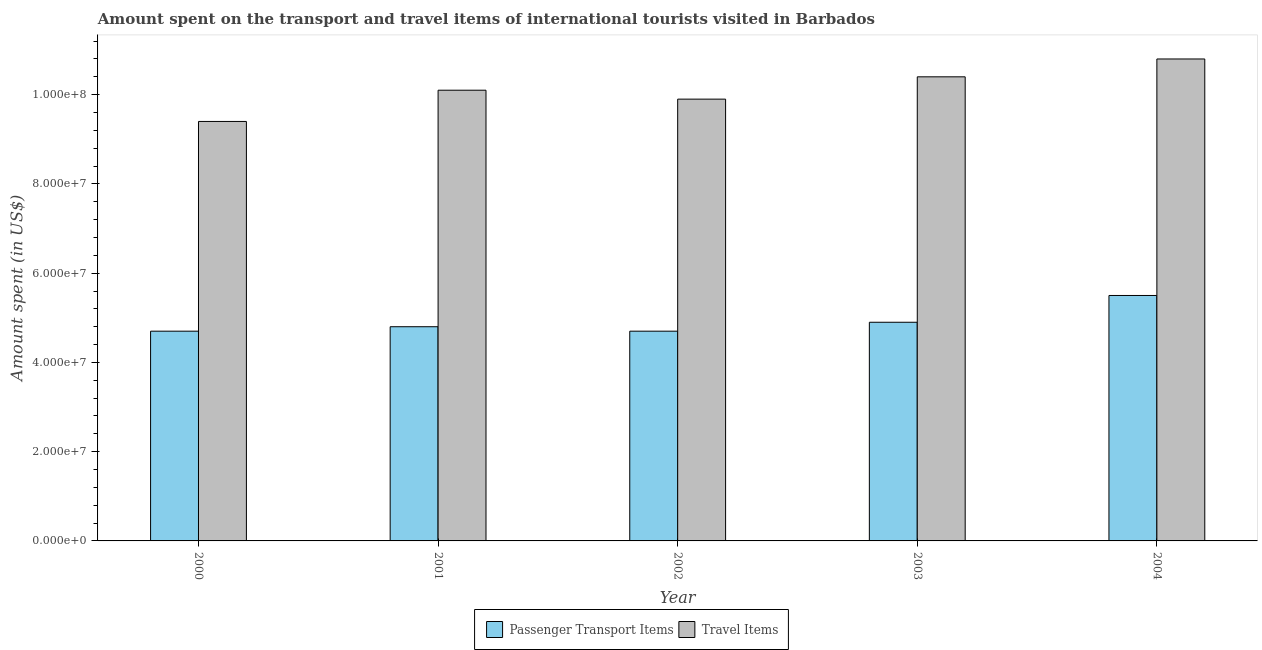How many groups of bars are there?
Offer a terse response. 5. How many bars are there on the 4th tick from the right?
Give a very brief answer. 2. What is the label of the 1st group of bars from the left?
Provide a short and direct response. 2000. What is the amount spent on passenger transport items in 2003?
Make the answer very short. 4.90e+07. Across all years, what is the maximum amount spent on passenger transport items?
Give a very brief answer. 5.50e+07. Across all years, what is the minimum amount spent on passenger transport items?
Ensure brevity in your answer.  4.70e+07. In which year was the amount spent in travel items minimum?
Provide a succinct answer. 2000. What is the total amount spent on passenger transport items in the graph?
Provide a succinct answer. 2.46e+08. What is the difference between the amount spent in travel items in 2001 and that in 2004?
Give a very brief answer. -7.00e+06. What is the difference between the amount spent in travel items in 2000 and the amount spent on passenger transport items in 2003?
Your answer should be compact. -1.00e+07. What is the average amount spent on passenger transport items per year?
Provide a short and direct response. 4.92e+07. In the year 2002, what is the difference between the amount spent in travel items and amount spent on passenger transport items?
Your answer should be very brief. 0. In how many years, is the amount spent in travel items greater than 52000000 US$?
Make the answer very short. 5. What is the ratio of the amount spent in travel items in 2001 to that in 2003?
Keep it short and to the point. 0.97. Is the amount spent on passenger transport items in 2001 less than that in 2004?
Keep it short and to the point. Yes. What is the difference between the highest and the second highest amount spent on passenger transport items?
Provide a succinct answer. 6.00e+06. What is the difference between the highest and the lowest amount spent on passenger transport items?
Your response must be concise. 8.00e+06. In how many years, is the amount spent on passenger transport items greater than the average amount spent on passenger transport items taken over all years?
Your answer should be very brief. 1. Is the sum of the amount spent in travel items in 2002 and 2003 greater than the maximum amount spent on passenger transport items across all years?
Make the answer very short. Yes. What does the 2nd bar from the left in 2002 represents?
Keep it short and to the point. Travel Items. What does the 2nd bar from the right in 2002 represents?
Your answer should be very brief. Passenger Transport Items. Are all the bars in the graph horizontal?
Your answer should be compact. No. Does the graph contain any zero values?
Your answer should be very brief. No. Does the graph contain grids?
Offer a very short reply. No. How are the legend labels stacked?
Your response must be concise. Horizontal. What is the title of the graph?
Offer a terse response. Amount spent on the transport and travel items of international tourists visited in Barbados. What is the label or title of the X-axis?
Give a very brief answer. Year. What is the label or title of the Y-axis?
Offer a very short reply. Amount spent (in US$). What is the Amount spent (in US$) in Passenger Transport Items in 2000?
Provide a short and direct response. 4.70e+07. What is the Amount spent (in US$) in Travel Items in 2000?
Keep it short and to the point. 9.40e+07. What is the Amount spent (in US$) of Passenger Transport Items in 2001?
Provide a short and direct response. 4.80e+07. What is the Amount spent (in US$) in Travel Items in 2001?
Make the answer very short. 1.01e+08. What is the Amount spent (in US$) in Passenger Transport Items in 2002?
Your response must be concise. 4.70e+07. What is the Amount spent (in US$) in Travel Items in 2002?
Your answer should be very brief. 9.90e+07. What is the Amount spent (in US$) in Passenger Transport Items in 2003?
Give a very brief answer. 4.90e+07. What is the Amount spent (in US$) of Travel Items in 2003?
Ensure brevity in your answer.  1.04e+08. What is the Amount spent (in US$) of Passenger Transport Items in 2004?
Make the answer very short. 5.50e+07. What is the Amount spent (in US$) in Travel Items in 2004?
Offer a very short reply. 1.08e+08. Across all years, what is the maximum Amount spent (in US$) of Passenger Transport Items?
Make the answer very short. 5.50e+07. Across all years, what is the maximum Amount spent (in US$) in Travel Items?
Offer a very short reply. 1.08e+08. Across all years, what is the minimum Amount spent (in US$) in Passenger Transport Items?
Ensure brevity in your answer.  4.70e+07. Across all years, what is the minimum Amount spent (in US$) in Travel Items?
Your answer should be compact. 9.40e+07. What is the total Amount spent (in US$) of Passenger Transport Items in the graph?
Provide a succinct answer. 2.46e+08. What is the total Amount spent (in US$) in Travel Items in the graph?
Your answer should be compact. 5.06e+08. What is the difference between the Amount spent (in US$) in Travel Items in 2000 and that in 2001?
Provide a short and direct response. -7.00e+06. What is the difference between the Amount spent (in US$) in Passenger Transport Items in 2000 and that in 2002?
Your answer should be very brief. 0. What is the difference between the Amount spent (in US$) of Travel Items in 2000 and that in 2002?
Offer a terse response. -5.00e+06. What is the difference between the Amount spent (in US$) in Travel Items in 2000 and that in 2003?
Give a very brief answer. -1.00e+07. What is the difference between the Amount spent (in US$) in Passenger Transport Items in 2000 and that in 2004?
Your answer should be very brief. -8.00e+06. What is the difference between the Amount spent (in US$) of Travel Items in 2000 and that in 2004?
Offer a very short reply. -1.40e+07. What is the difference between the Amount spent (in US$) of Passenger Transport Items in 2001 and that in 2002?
Your answer should be compact. 1.00e+06. What is the difference between the Amount spent (in US$) of Passenger Transport Items in 2001 and that in 2004?
Make the answer very short. -7.00e+06. What is the difference between the Amount spent (in US$) in Travel Items in 2001 and that in 2004?
Offer a terse response. -7.00e+06. What is the difference between the Amount spent (in US$) in Travel Items in 2002 and that in 2003?
Provide a short and direct response. -5.00e+06. What is the difference between the Amount spent (in US$) of Passenger Transport Items in 2002 and that in 2004?
Provide a short and direct response. -8.00e+06. What is the difference between the Amount spent (in US$) in Travel Items in 2002 and that in 2004?
Your answer should be compact. -9.00e+06. What is the difference between the Amount spent (in US$) of Passenger Transport Items in 2003 and that in 2004?
Ensure brevity in your answer.  -6.00e+06. What is the difference between the Amount spent (in US$) in Passenger Transport Items in 2000 and the Amount spent (in US$) in Travel Items in 2001?
Give a very brief answer. -5.40e+07. What is the difference between the Amount spent (in US$) of Passenger Transport Items in 2000 and the Amount spent (in US$) of Travel Items in 2002?
Offer a terse response. -5.20e+07. What is the difference between the Amount spent (in US$) of Passenger Transport Items in 2000 and the Amount spent (in US$) of Travel Items in 2003?
Provide a short and direct response. -5.70e+07. What is the difference between the Amount spent (in US$) in Passenger Transport Items in 2000 and the Amount spent (in US$) in Travel Items in 2004?
Provide a succinct answer. -6.10e+07. What is the difference between the Amount spent (in US$) of Passenger Transport Items in 2001 and the Amount spent (in US$) of Travel Items in 2002?
Provide a short and direct response. -5.10e+07. What is the difference between the Amount spent (in US$) of Passenger Transport Items in 2001 and the Amount spent (in US$) of Travel Items in 2003?
Offer a very short reply. -5.60e+07. What is the difference between the Amount spent (in US$) in Passenger Transport Items in 2001 and the Amount spent (in US$) in Travel Items in 2004?
Provide a short and direct response. -6.00e+07. What is the difference between the Amount spent (in US$) of Passenger Transport Items in 2002 and the Amount spent (in US$) of Travel Items in 2003?
Ensure brevity in your answer.  -5.70e+07. What is the difference between the Amount spent (in US$) of Passenger Transport Items in 2002 and the Amount spent (in US$) of Travel Items in 2004?
Give a very brief answer. -6.10e+07. What is the difference between the Amount spent (in US$) in Passenger Transport Items in 2003 and the Amount spent (in US$) in Travel Items in 2004?
Offer a very short reply. -5.90e+07. What is the average Amount spent (in US$) in Passenger Transport Items per year?
Your response must be concise. 4.92e+07. What is the average Amount spent (in US$) in Travel Items per year?
Keep it short and to the point. 1.01e+08. In the year 2000, what is the difference between the Amount spent (in US$) in Passenger Transport Items and Amount spent (in US$) in Travel Items?
Provide a succinct answer. -4.70e+07. In the year 2001, what is the difference between the Amount spent (in US$) in Passenger Transport Items and Amount spent (in US$) in Travel Items?
Keep it short and to the point. -5.30e+07. In the year 2002, what is the difference between the Amount spent (in US$) in Passenger Transport Items and Amount spent (in US$) in Travel Items?
Provide a succinct answer. -5.20e+07. In the year 2003, what is the difference between the Amount spent (in US$) in Passenger Transport Items and Amount spent (in US$) in Travel Items?
Provide a short and direct response. -5.50e+07. In the year 2004, what is the difference between the Amount spent (in US$) in Passenger Transport Items and Amount spent (in US$) in Travel Items?
Make the answer very short. -5.30e+07. What is the ratio of the Amount spent (in US$) in Passenger Transport Items in 2000 to that in 2001?
Ensure brevity in your answer.  0.98. What is the ratio of the Amount spent (in US$) in Travel Items in 2000 to that in 2001?
Your answer should be very brief. 0.93. What is the ratio of the Amount spent (in US$) of Travel Items in 2000 to that in 2002?
Offer a terse response. 0.95. What is the ratio of the Amount spent (in US$) in Passenger Transport Items in 2000 to that in 2003?
Offer a terse response. 0.96. What is the ratio of the Amount spent (in US$) of Travel Items in 2000 to that in 2003?
Provide a succinct answer. 0.9. What is the ratio of the Amount spent (in US$) of Passenger Transport Items in 2000 to that in 2004?
Your response must be concise. 0.85. What is the ratio of the Amount spent (in US$) of Travel Items in 2000 to that in 2004?
Your answer should be compact. 0.87. What is the ratio of the Amount spent (in US$) in Passenger Transport Items in 2001 to that in 2002?
Offer a very short reply. 1.02. What is the ratio of the Amount spent (in US$) in Travel Items in 2001 to that in 2002?
Keep it short and to the point. 1.02. What is the ratio of the Amount spent (in US$) in Passenger Transport Items in 2001 to that in 2003?
Provide a succinct answer. 0.98. What is the ratio of the Amount spent (in US$) in Travel Items in 2001 to that in 2003?
Your answer should be compact. 0.97. What is the ratio of the Amount spent (in US$) of Passenger Transport Items in 2001 to that in 2004?
Keep it short and to the point. 0.87. What is the ratio of the Amount spent (in US$) of Travel Items in 2001 to that in 2004?
Your response must be concise. 0.94. What is the ratio of the Amount spent (in US$) in Passenger Transport Items in 2002 to that in 2003?
Provide a succinct answer. 0.96. What is the ratio of the Amount spent (in US$) in Travel Items in 2002 to that in 2003?
Make the answer very short. 0.95. What is the ratio of the Amount spent (in US$) in Passenger Transport Items in 2002 to that in 2004?
Offer a terse response. 0.85. What is the ratio of the Amount spent (in US$) of Travel Items in 2002 to that in 2004?
Your answer should be compact. 0.92. What is the ratio of the Amount spent (in US$) in Passenger Transport Items in 2003 to that in 2004?
Make the answer very short. 0.89. What is the difference between the highest and the second highest Amount spent (in US$) in Passenger Transport Items?
Your response must be concise. 6.00e+06. What is the difference between the highest and the second highest Amount spent (in US$) of Travel Items?
Your response must be concise. 4.00e+06. What is the difference between the highest and the lowest Amount spent (in US$) in Travel Items?
Provide a short and direct response. 1.40e+07. 